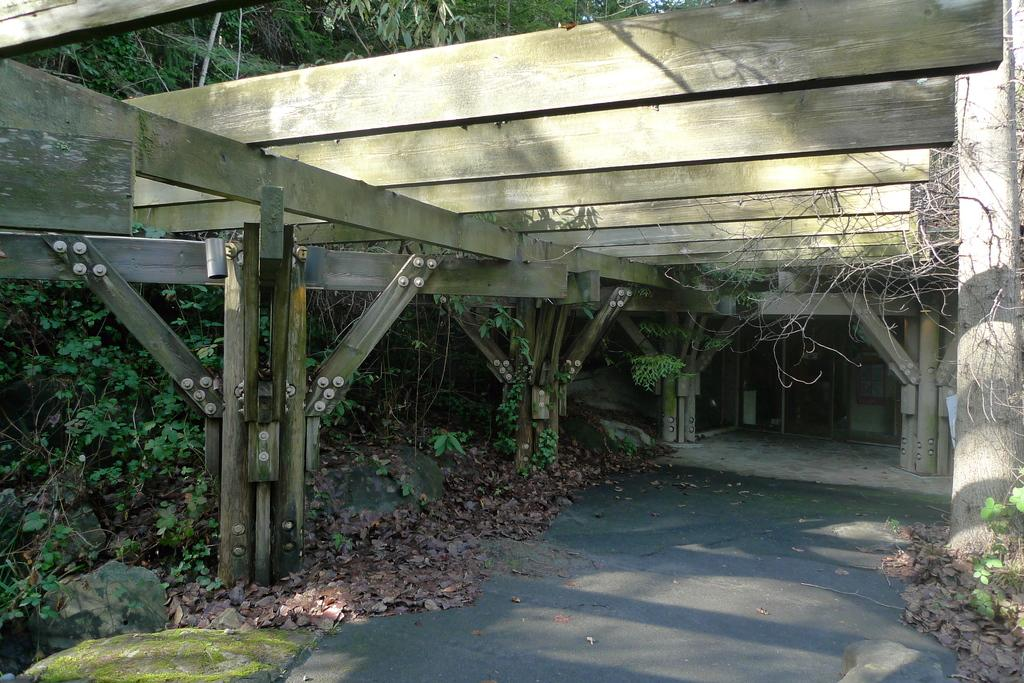What is the main feature of the image? There is a road in the image. What can be seen on the left side of the road? There are plants and trees to the left of the road. What type of structure is present at the top of the image? There is a wooden bridge at the top of the image. What type of pets can be seen playing with a stranger on the wooden bridge in the image? There are no pets or strangers present on the wooden bridge in the image. 